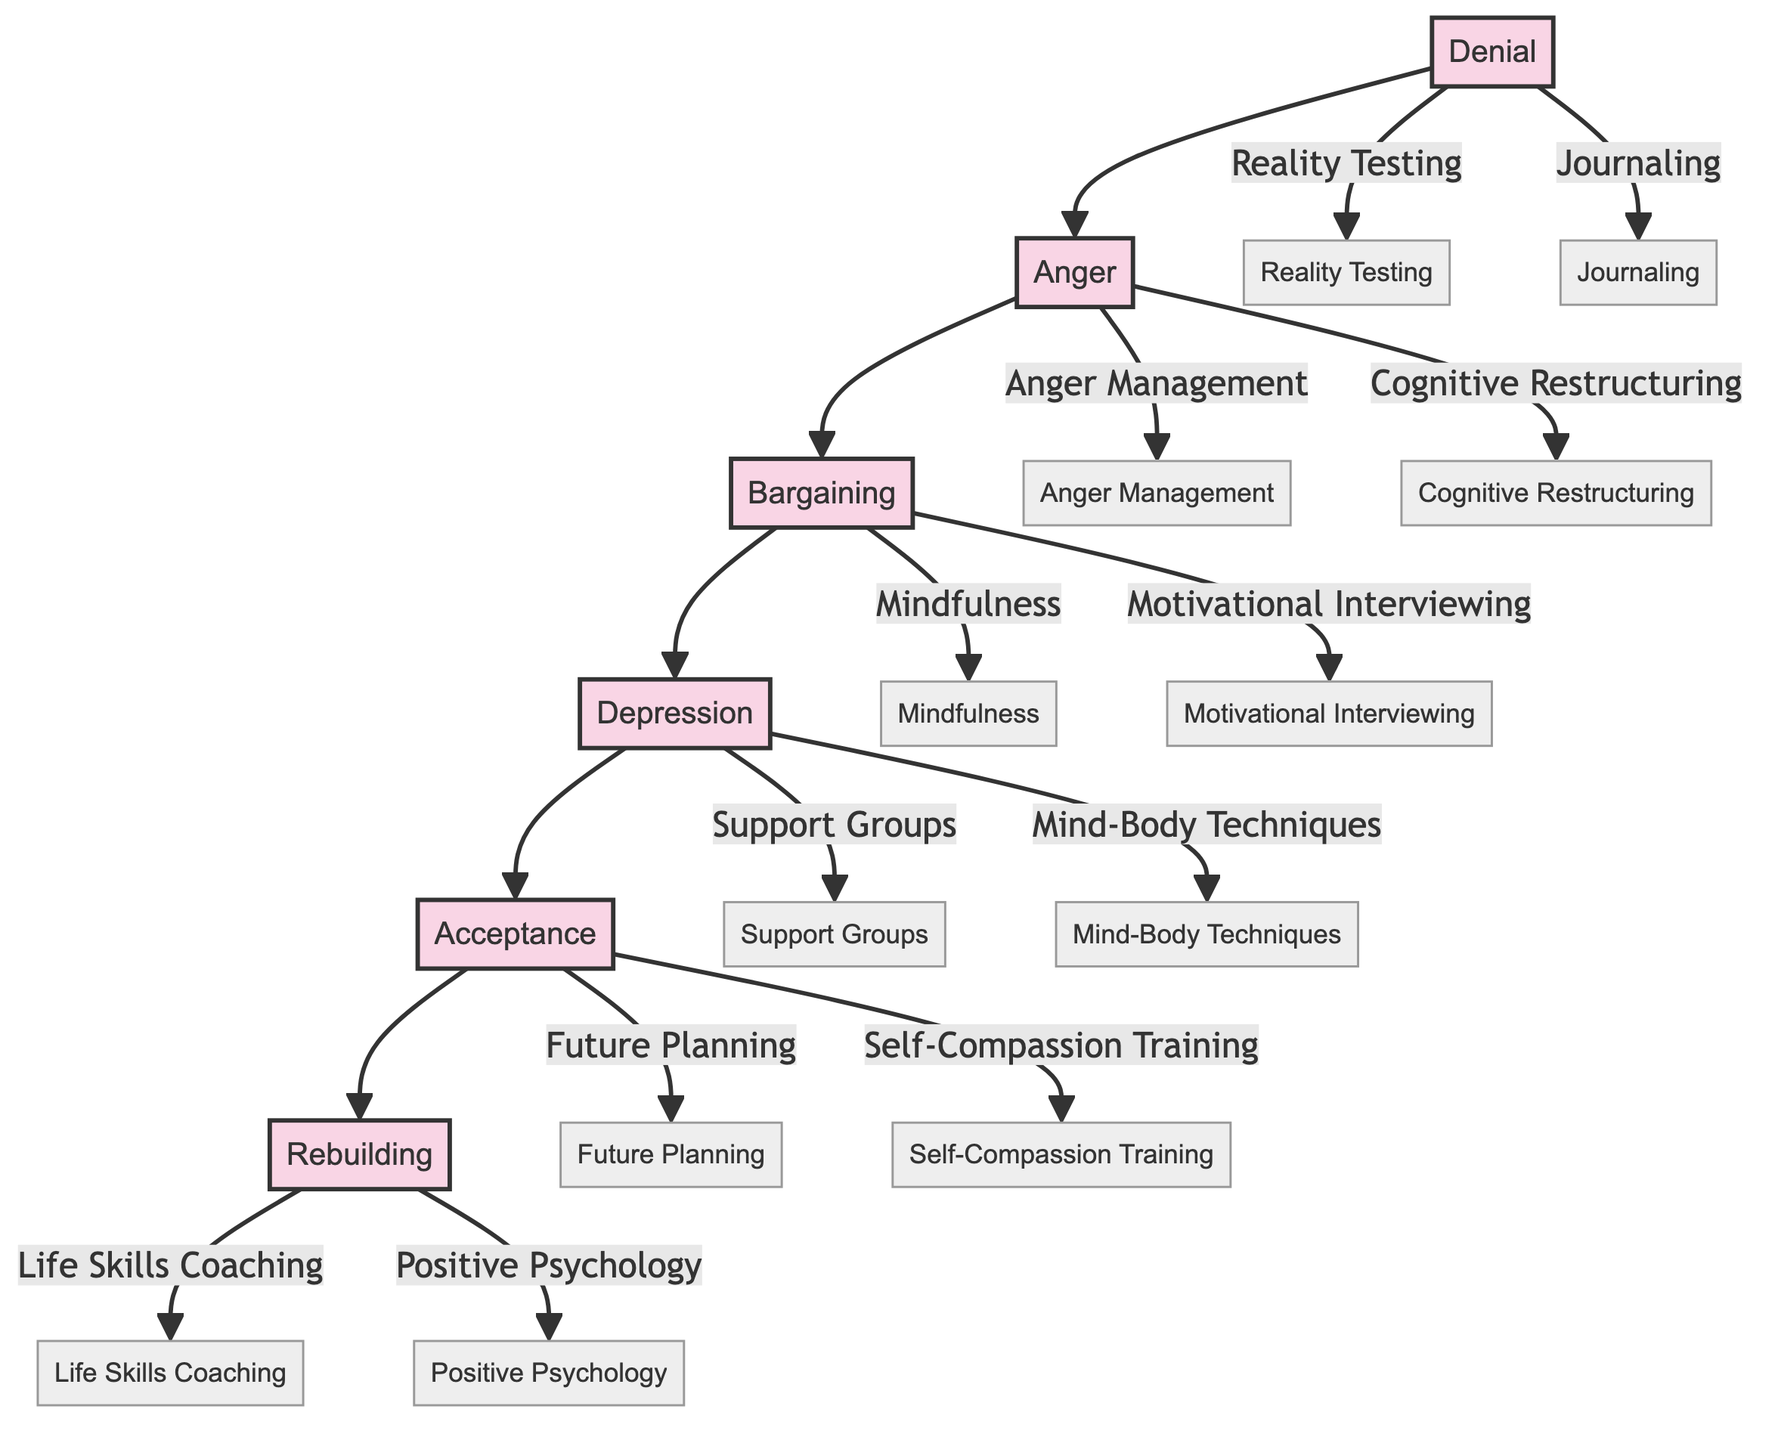What is the first emotional stage of divorce recovery? The diagram shows the stages of divorce recovery starting from Denial, which is the first stage listed.
Answer: Denial How many therapeutic interventions are associated with the Depression stage? The Depression stage has two interventions listed: Support Groups and Mind-Body Techniques, thus making the total count two.
Answer: 2 What is the last emotional stage before Rebuilding? The stage directly preceding Rebuilding in the diagram is Acceptance, as it flows into Rebuilding.
Answer: Acceptance What therapeutic intervention is linked to the Anger stage that focuses on thoughts? The Anger stage lists Cognitive Restructuring as a therapeutic intervention aimed at helping clients reframe negative thoughts, addressing thought patterns directly.
Answer: Cognitive Restructuring How many total stages are represented in the diagram? By counting all the emotional stages from Denial to Rebuilding, we identify six stages of divorce recovery in total.
Answer: 6 Which emotional stage allows for Future Planning as a therapeutic intervention? Future Planning is connected to Acceptance, indicating that this intervention is recommended once individuals reach this stage.
Answer: Acceptance What is the primary focus of the therapeutic intervention Mindfulness? Mindfulness is aimed at encouraging present-moment awareness, which is intended to reduce obsessive thought patterns.
Answer: Present-moment awareness Which stage comes immediately after Bargaining? Following Bargaining, the next stage in the flow of the diagram is Depression, thus indicating the transition that takes place in emotional recovery.
Answer: Depression Which therapeutic intervention is aimed at emotional expression in the Anger stage? Anger Management is the intervention that focuses on techniques to constructively manage and express feelings of anger during this emotional stage.
Answer: Anger Management 